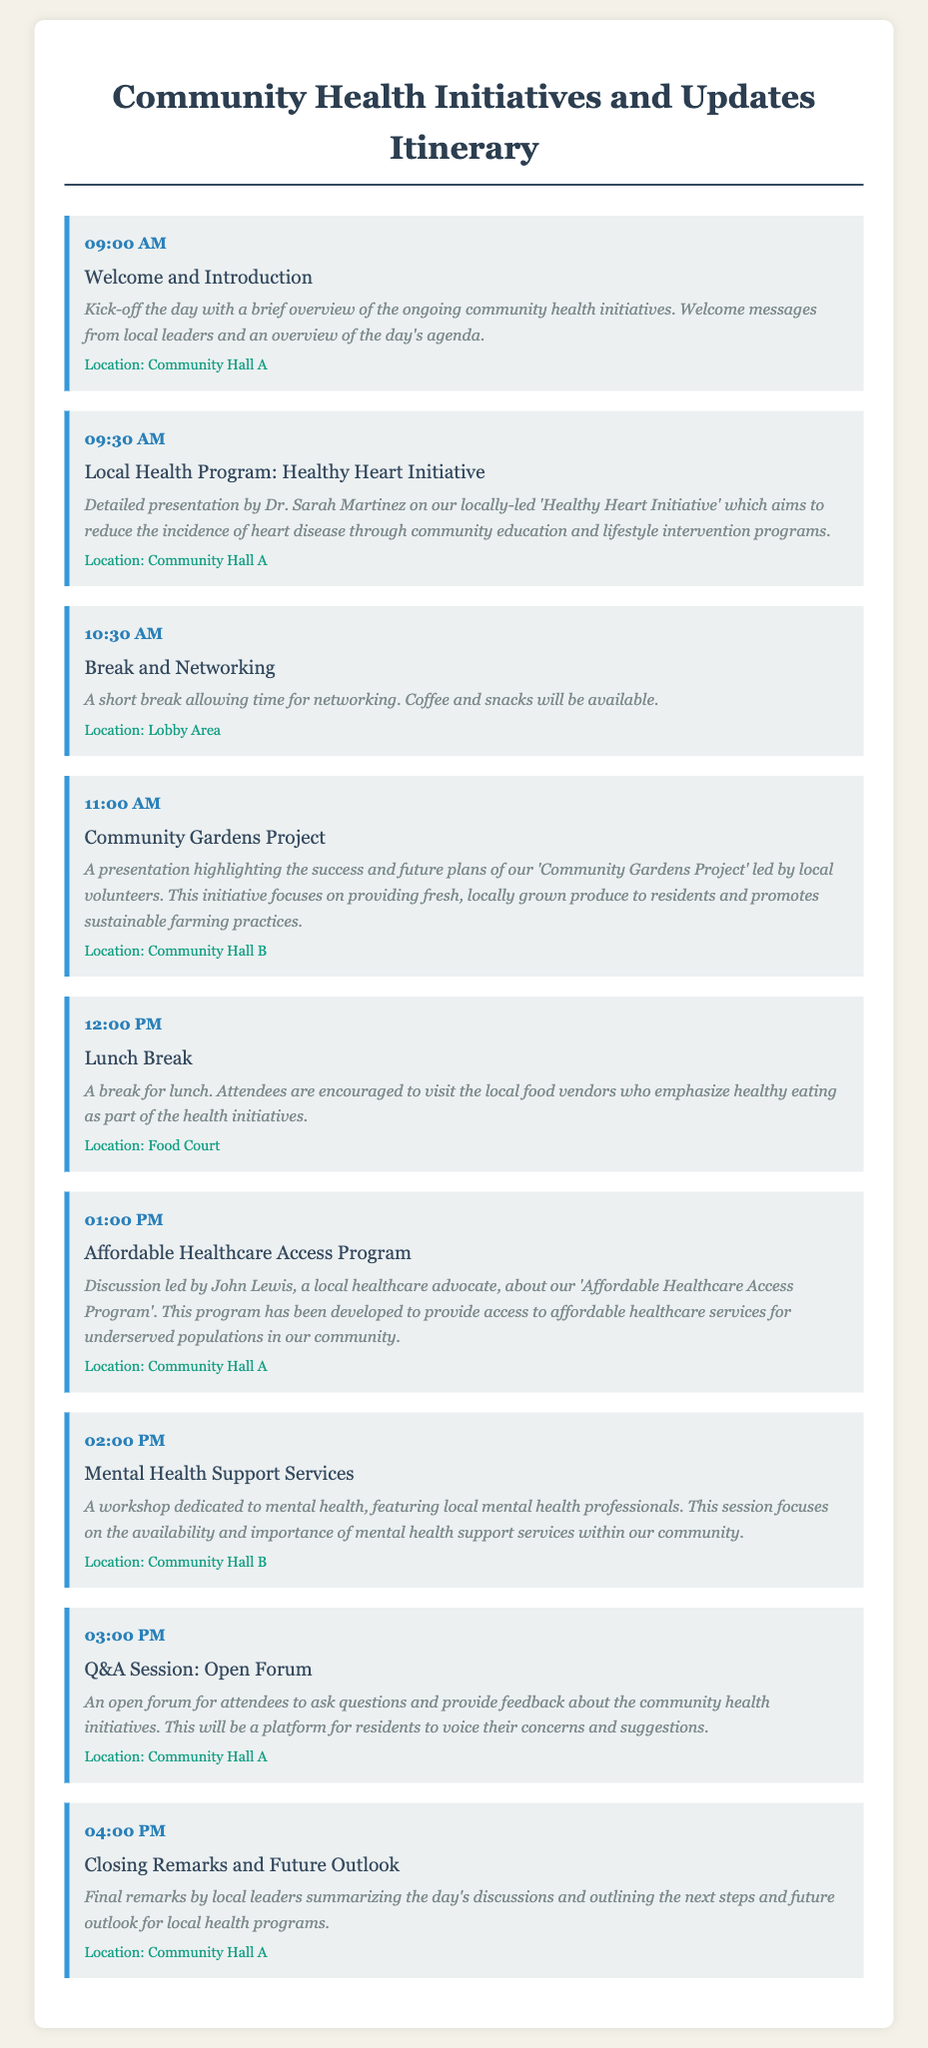What time does the Welcome and Introduction start? The Welcome and Introduction starts at 09:00 AM, as indicated in the itinerary.
Answer: 09:00 AM Who is leading the presentation on the Healthy Heart Initiative? The presentation on the Healthy Heart Initiative is led by Dr. Sarah Martinez.
Answer: Dr. Sarah Martinez What is the focus of the Community Gardens Project? The Community Gardens Project focuses on providing fresh, locally grown produce to residents and promoting sustainable farming practices.
Answer: Fresh, locally grown produce How long is the break for networking? The break for networking takes place at 10:30 AM, right after the first two sessions, which is a short break.
Answer: Short break What location hosts the Q&A Session? The Q&A Session is hosted in Community Hall A.
Answer: Community Hall A What are the local food vendors emphasizing during the lunch break? The local food vendors emphasize healthy eating as part of the health initiatives during the lunch break.
Answer: Healthy eating What type of professionals feature in the Mental Health Support Services workshop? Local mental health professionals feature in the Mental Health Support Services workshop.
Answer: Local mental health professionals What is the purpose of the Closing Remarks session? The purpose of the Closing Remarks session is to summarize the day's discussions and outline the next steps and future outlook for local health programs.
Answer: Summarize discussions What is the duration of the lunch break? The duration of the lunch break is not explicitly stated, but it follows the 12:00 PM session and allows time for attendees to visit food vendors.
Answer: Not explicitly stated 